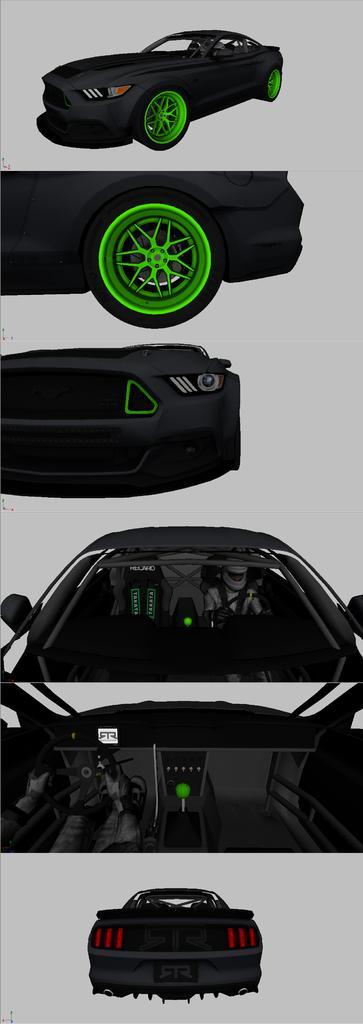Please provide a concise description of this image. This picture is collage of different pictures. In each picture, there is part of a car. 